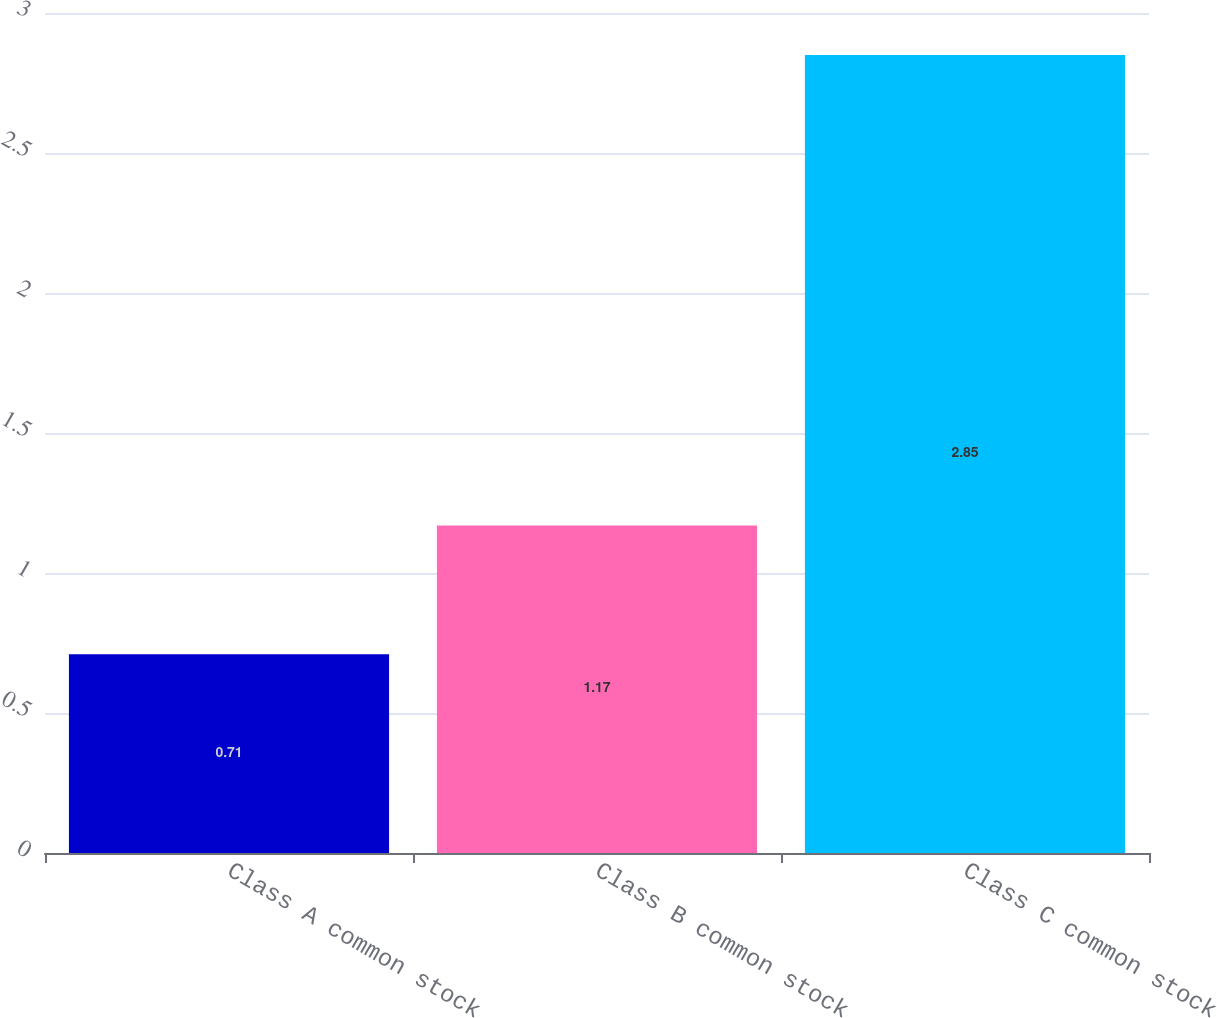Convert chart to OTSL. <chart><loc_0><loc_0><loc_500><loc_500><bar_chart><fcel>Class A common stock<fcel>Class B common stock<fcel>Class C common stock<nl><fcel>0.71<fcel>1.17<fcel>2.85<nl></chart> 